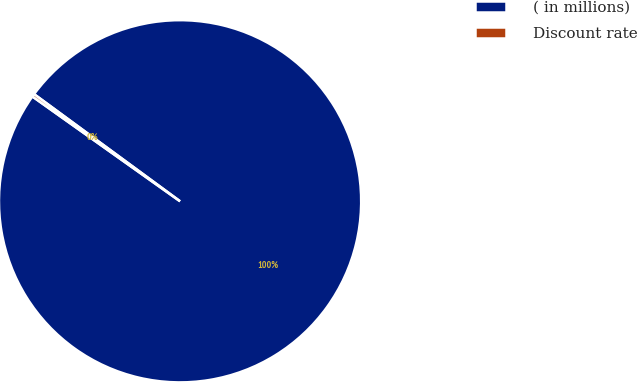Convert chart to OTSL. <chart><loc_0><loc_0><loc_500><loc_500><pie_chart><fcel>( in millions)<fcel>Discount rate<nl><fcel>99.75%<fcel>0.25%<nl></chart> 